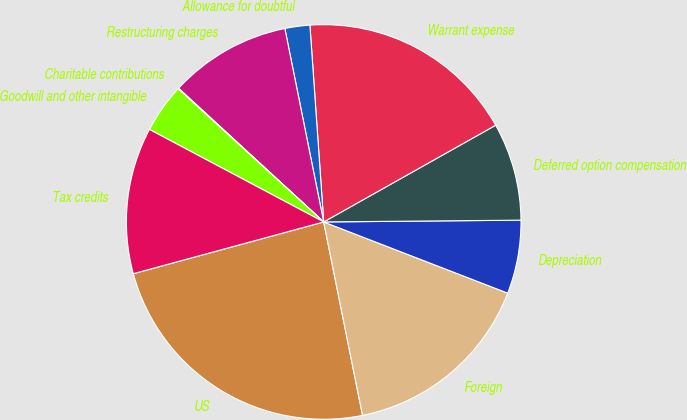Convert chart. <chart><loc_0><loc_0><loc_500><loc_500><pie_chart><fcel>US<fcel>Foreign<fcel>Depreciation<fcel>Deferred option compensation<fcel>Warrant expense<fcel>Allowance for doubtful<fcel>Restructuring charges<fcel>Charitable contributions<fcel>Goodwill and other intangible<fcel>Tax credits<nl><fcel>23.93%<fcel>15.97%<fcel>6.02%<fcel>8.01%<fcel>17.96%<fcel>2.04%<fcel>10.0%<fcel>0.05%<fcel>4.03%<fcel>11.99%<nl></chart> 